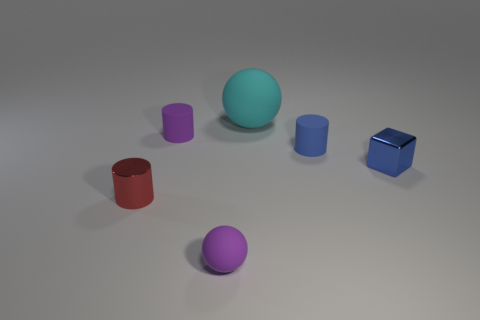How many blue cubes are the same material as the big object? Based on the image, there are no blue cubes that appear to be made of the same material as the large central object, which seems to be a smooth, matte sphere. All the smaller objects, including the blue cube, have a reflective surface, indicating a different material. 